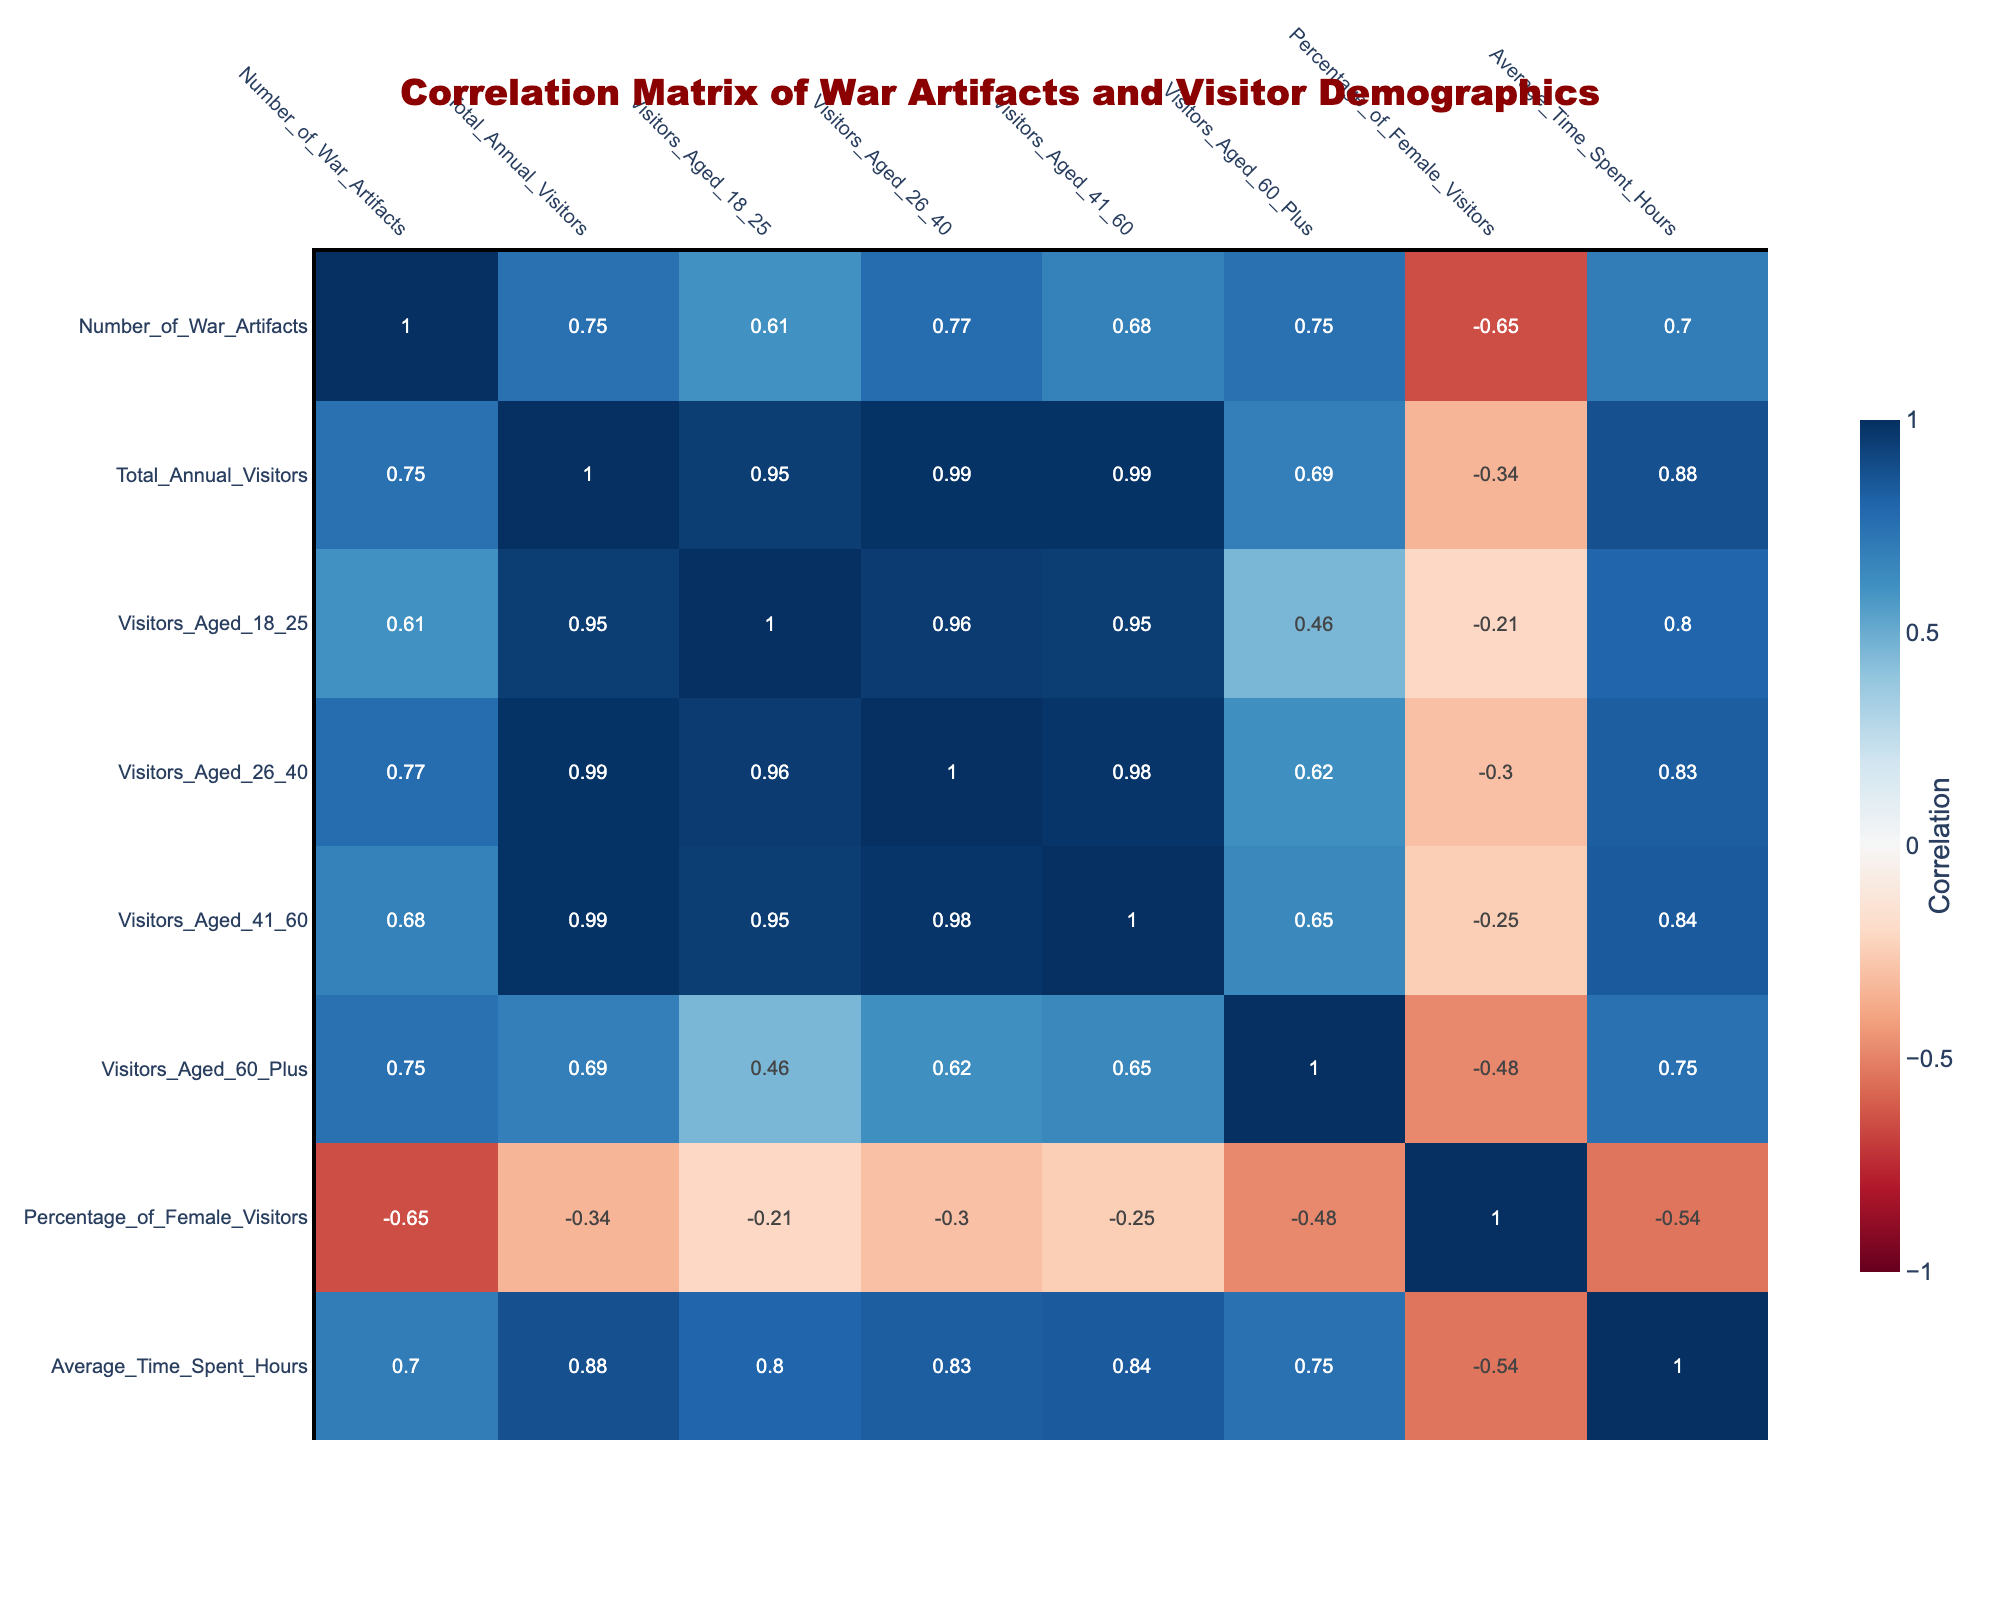What is the highest number of war artifacts displayed in a museum? The data shows the number of war artifacts for each museum. The highest value is 2000 artifacts at the Imperial War Museum.
Answer: 2000 What percentage of visitors aged 18-25 does the National WWII Museum attract? The National WWII Museum has 150000 visitors aged 18-25 out of 850000 total annual visitors. To find the percentage, we calculate (150000 / 850000) * 100, which equals approximately 17.65%.
Answer: 17.65% Which museum has the highest average time spent by visitors? By comparing the average time spent by visitors across all museums, the National Museum of American History has the highest average time of 2.4 hours.
Answer: 2.4 hours Is it true that the museum with the most war artifacts also attracts the largest number of visitors? The museum with the most war artifacts is the Imperial War Museum (2000 artifacts), which attracts 600000 visitors. The highest number of visitors is at the Smithsonian National Museum of American History with 1000000 visitors but 1200 artifacts. Thus, the statement is false.
Answer: No What is the total number of visitors aged 41-60 across all museums? To find the total number of visitors aged 41-60, we sum the numbers from each museum: 250000 + 150000 + 90000 + 40000 + 100000 + 50000 + 300000 + 80000 + 70000 + 50000 = 950000.
Answer: 950000 Which museum has the highest percentage of female visitors? By examining the percentage of female visitors for each museum, the Museum of the American Revolution has the highest percentage at 55%.
Answer: 55% How many more war artifacts does the Imperial War Museum have compared to The Museum of War History? The Imperial War Museum has 2000 artifacts, while The Museum of War History has 450 artifacts. The difference is 2000 - 450 = 1550 artifacts.
Answer: 1550 What is the average number of total annual visitors across all museums? To calculate the average number of total annual visitors, we sum the total visitors: 850000 + 600000 + 300000 + 150000 + 400000 + 200000 + 1000000 + 250000 + 350000 + 180000 = 4050000, then divide by the number of museums (10). So, the average is 405000.
Answer: 405000 Does the average time spent increase with age in the museums based on the data? By checking the average time spent at different museums, the values do not consistently increase with age groups. They vary, so we cannot conclude that it increases with age.
Answer: No 